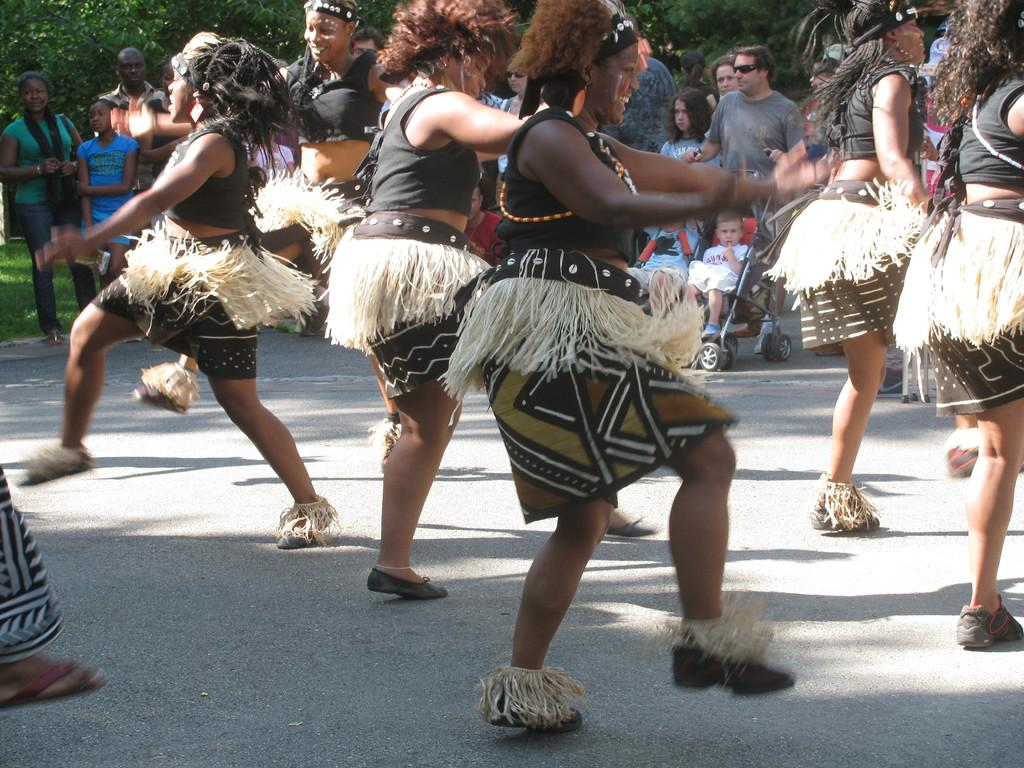What is happening in the image involving the group of people? Some people are standing, while others are dancing. Where are the people located in the image? The people are on the road. Is there any additional information about the group of people? Yes, there is a stroller with a child in it}. What can be seen in the background of the image? Trees are visible in the background of the image. What type of lawyer is sitting on the sofa in the image? There is no lawyer or sofa present in the image. Who is the uncle of the child in the stroller in the image? The image does not provide information about the relationship between the people in the group, so we cannot determine who the uncle of the child in the stroller is. 